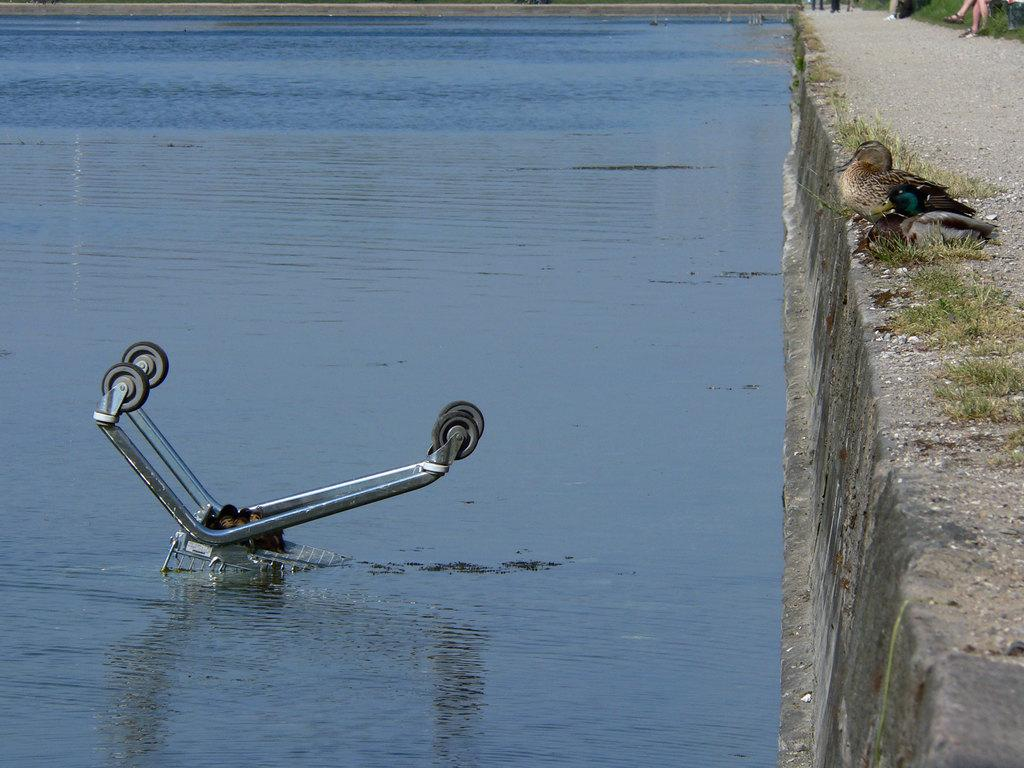What is in the water in the image? There is an object in the water that resembles a trolley wheel. What else can be seen in the image besides the object in the water? There is a bird on the right side of the image. What country is the bird from in the image? There is no information about the bird's country of origin in the image. Is the bird performing a skate trick in the image? There is no indication of the bird performing any tricks, including skate tricks, in the image. 